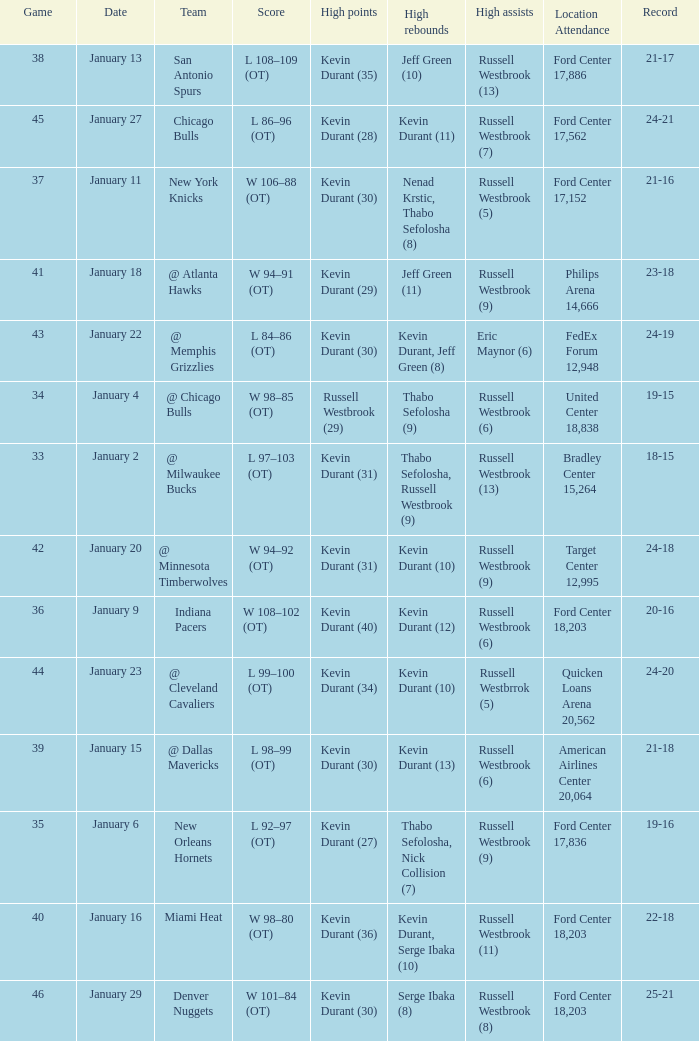Name the location attendance for january 18 Philips Arena 14,666. 